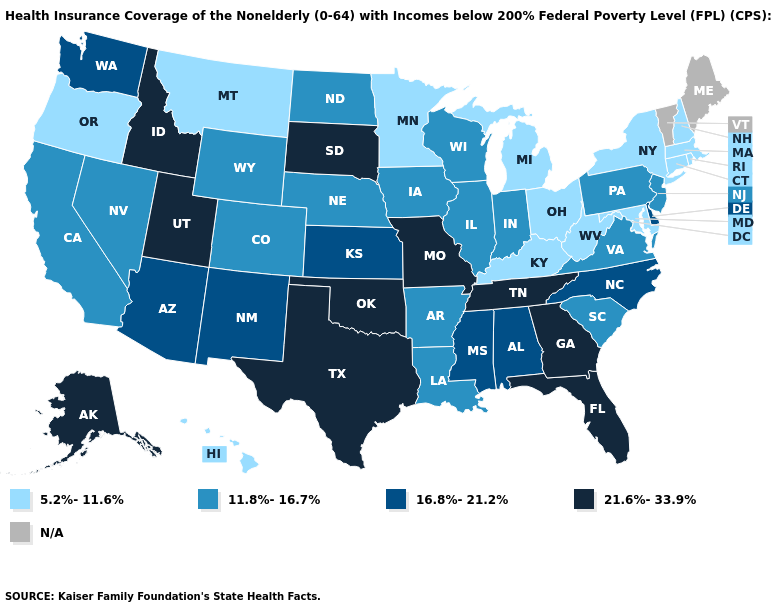Name the states that have a value in the range N/A?
Write a very short answer. Maine, Vermont. What is the highest value in states that border Montana?
Answer briefly. 21.6%-33.9%. Among the states that border California , does Nevada have the highest value?
Be succinct. No. Name the states that have a value in the range 16.8%-21.2%?
Write a very short answer. Alabama, Arizona, Delaware, Kansas, Mississippi, New Mexico, North Carolina, Washington. Which states have the lowest value in the USA?
Keep it brief. Connecticut, Hawaii, Kentucky, Maryland, Massachusetts, Michigan, Minnesota, Montana, New Hampshire, New York, Ohio, Oregon, Rhode Island, West Virginia. What is the highest value in the South ?
Quick response, please. 21.6%-33.9%. Which states have the lowest value in the West?
Be succinct. Hawaii, Montana, Oregon. What is the value of Kansas?
Quick response, please. 16.8%-21.2%. What is the lowest value in states that border South Dakota?
Write a very short answer. 5.2%-11.6%. Which states hav the highest value in the South?
Concise answer only. Florida, Georgia, Oklahoma, Tennessee, Texas. Which states have the lowest value in the USA?
Keep it brief. Connecticut, Hawaii, Kentucky, Maryland, Massachusetts, Michigan, Minnesota, Montana, New Hampshire, New York, Ohio, Oregon, Rhode Island, West Virginia. Among the states that border Utah , does Wyoming have the lowest value?
Short answer required. Yes. 